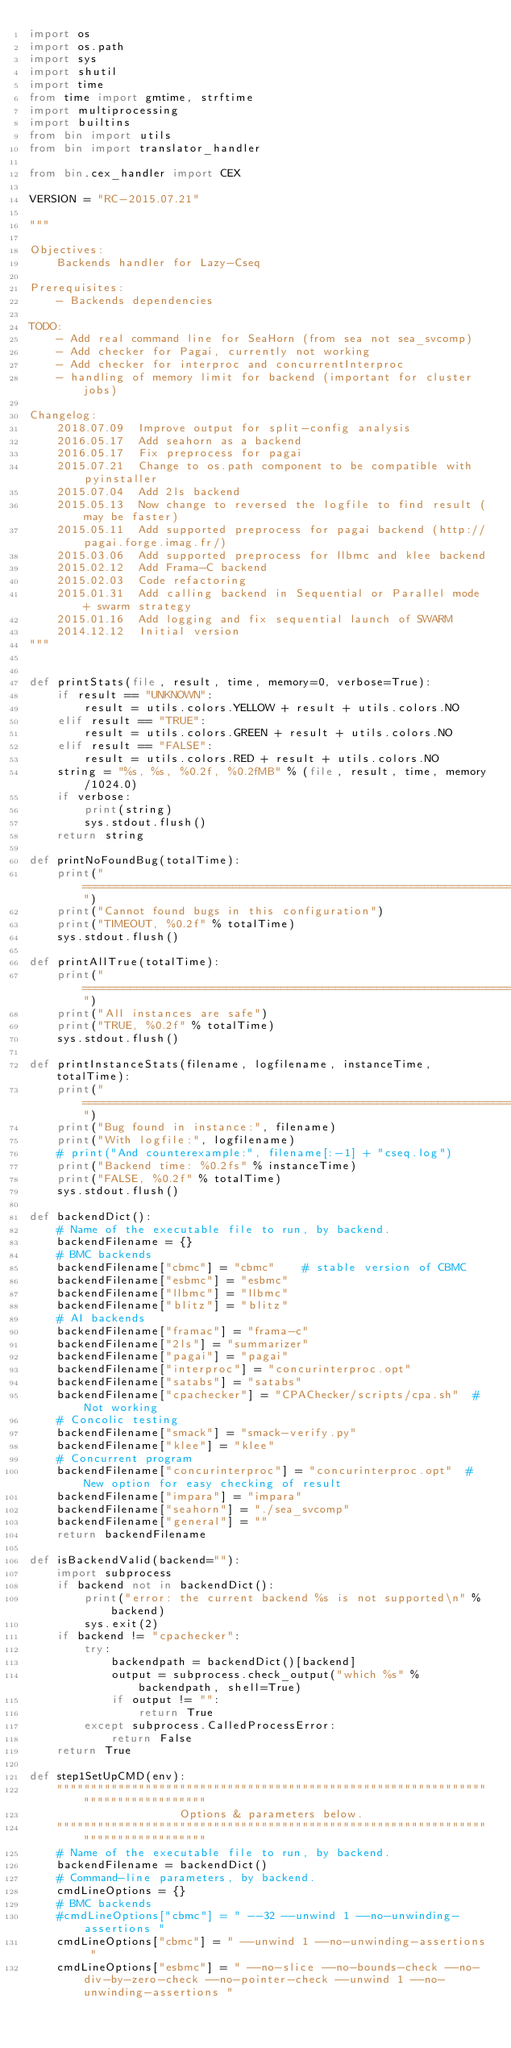<code> <loc_0><loc_0><loc_500><loc_500><_Python_>import os
import os.path
import sys
import shutil
import time
from time import gmtime, strftime
import multiprocessing
import builtins
from bin import utils
from bin import translator_handler

from bin.cex_handler import CEX

VERSION = "RC-2015.07.21"

"""

Objectives:
    Backends handler for Lazy-Cseq

Prerequisites:
    - Backends dependencies

TODO:
    - Add real command line for SeaHorn (from sea not sea_svcomp)
    - Add checker for Pagai, currently not working
    - Add checker for interproc and concurrentInterproc
    - handling of memory limit for backend (important for cluster jobs)

Changelog:
    2018.07.09  Improve output for split-config analysis
    2016.05.17  Add seahorn as a backend
    2016.05.17  Fix preprocess for pagai
    2015.07.21  Change to os.path component to be compatible with pyinstaller
    2015.07.04  Add 2ls backend
    2015.05.13  Now change to reversed the logfile to find result (may be faster)
    2015.05.11  Add supported preprocess for pagai backend (http://pagai.forge.imag.fr/)
    2015.03.06  Add supported preprocess for llbmc and klee backend
    2015.02.12  Add Frama-C backend
    2015.02.03  Code refactoring
    2015.01.31  Add calling backend in Sequential or Parallel mode + swarm strategy
    2015.01.16  Add logging and fix sequential launch of SWARM
    2014.12.12  Initial version
"""


def printStats(file, result, time, memory=0, verbose=True):
    if result == "UNKNOWN":
        result = utils.colors.YELLOW + result + utils.colors.NO
    elif result == "TRUE":
        result = utils.colors.GREEN + result + utils.colors.NO
    elif result == "FALSE":
        result = utils.colors.RED + result + utils.colors.NO
    string = "%s, %s, %0.2f, %0.2fMB" % (file, result, time, memory/1024.0)
    if verbose:
        print(string)
        sys.stdout.flush()
    return string

def printNoFoundBug(totalTime):
    print("============================================================================")
    print("Cannot found bugs in this configuration")
    print("TIMEOUT, %0.2f" % totalTime)
    sys.stdout.flush()

def printAllTrue(totalTime):
    print("============================================================================")
    print("All instances are safe")
    print("TRUE, %0.2f" % totalTime)
    sys.stdout.flush()

def printInstanceStats(filename, logfilename, instanceTime, totalTime):
    print("============================================================================")
    print("Bug found in instance:", filename)
    print("With logfile:", logfilename)
    # print("And counterexample:", filename[:-1] + "cseq.log")
    print("Backend time: %0.2fs" % instanceTime)
    print("FALSE, %0.2f" % totalTime)
    sys.stdout.flush()

def backendDict():
    # Name of the executable file to run, by backend.
    backendFilename = {}
    # BMC backends
    backendFilename["cbmc"] = "cbmc"    # stable version of CBMC
    backendFilename["esbmc"] = "esbmc"
    backendFilename["llbmc"] = "llbmc"
    backendFilename["blitz"] = "blitz"
    # AI backends
    backendFilename["framac"] = "frama-c"
    backendFilename["2ls"] = "summarizer"
    backendFilename["pagai"] = "pagai"
    backendFilename["interproc"] = "concurinterproc.opt"
    backendFilename["satabs"] = "satabs"
    backendFilename["cpachecker"] = "CPAChecker/scripts/cpa.sh"  # Not working
    # Concolic testing
    backendFilename["smack"] = "smack-verify.py"
    backendFilename["klee"] = "klee"
    # Concurrent program
    backendFilename["concurinterproc"] = "concurinterproc.opt"  # New option for easy checking of result
    backendFilename["impara"] = "impara"
    backendFilename["seahorn"] = "./sea_svcomp"
    backendFilename["general"] = ""
    return backendFilename

def isBackendValid(backend=""):
    import subprocess
    if backend not in backendDict():
        print("error: the current backend %s is not supported\n" % backend)
        sys.exit(2)
    if backend != "cpachecker":
        try:
            backendpath = backendDict()[backend]
            output = subprocess.check_output("which %s" % backendpath, shell=True)
            if output != "":
                return True
        except subprocess.CalledProcessError:
            return False
    return True

def step1SetUpCMD(env):
    """""""""""""""""""""""""""""""""""""""""""""""""""""""""""""""""""""""""""""""""
                      Options & parameters below.
    """""""""""""""""""""""""""""""""""""""""""""""""""""""""""""""""""""""""""""""""
    # Name of the executable file to run, by backend.
    backendFilename = backendDict()
    # Command-line parameters, by backend.
    cmdLineOptions = {}
    # BMC backends
    #cmdLineOptions["cbmc"] = " --32 --unwind 1 --no-unwinding-assertions "
    cmdLineOptions["cbmc"] = " --unwind 1 --no-unwinding-assertions "
    cmdLineOptions["esbmc"] = " --no-slice --no-bounds-check --no-div-by-zero-check --no-pointer-check --unwind 1 --no-unwinding-assertions "</code> 